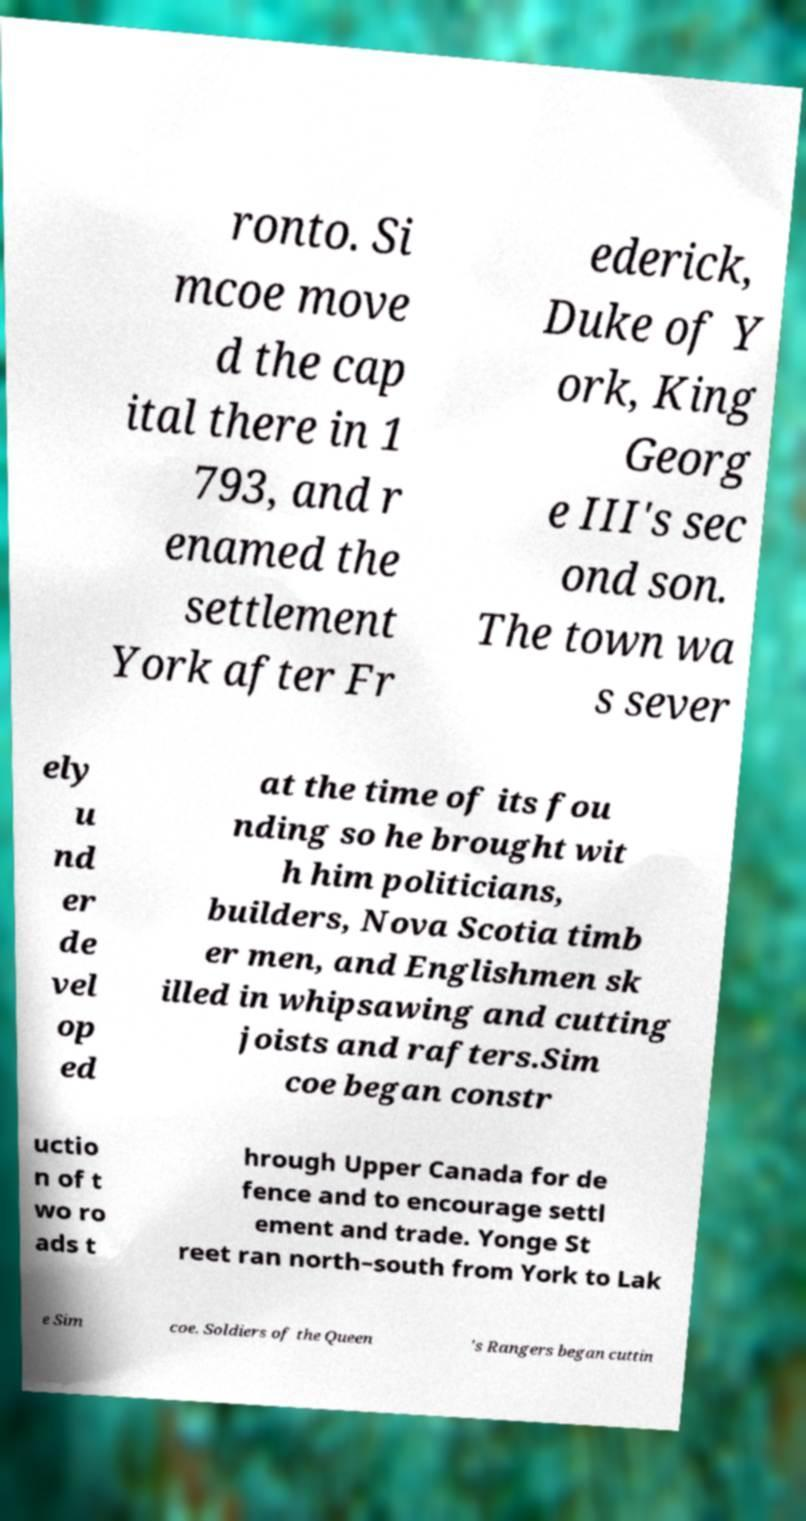There's text embedded in this image that I need extracted. Can you transcribe it verbatim? ronto. Si mcoe move d the cap ital there in 1 793, and r enamed the settlement York after Fr ederick, Duke of Y ork, King Georg e III's sec ond son. The town wa s sever ely u nd er de vel op ed at the time of its fou nding so he brought wit h him politicians, builders, Nova Scotia timb er men, and Englishmen sk illed in whipsawing and cutting joists and rafters.Sim coe began constr uctio n of t wo ro ads t hrough Upper Canada for de fence and to encourage settl ement and trade. Yonge St reet ran north–south from York to Lak e Sim coe. Soldiers of the Queen 's Rangers began cuttin 